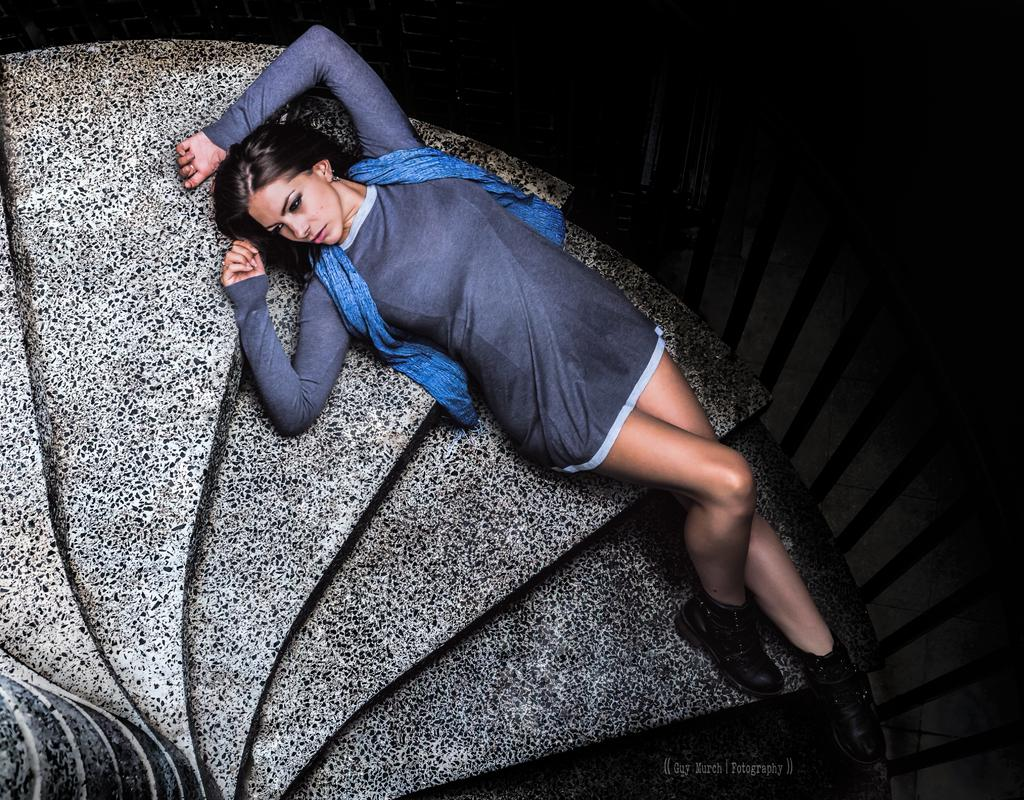What is the woman in the image doing? The woman is lying on the stairs in the image. What can be seen on the right side of the image? There is railing on the right side of the image. How would you describe the lighting in the image? The view is dark in the image. Is there any text or marking visible in the image? Yes, there is a watermark at the bottom of the image. Can you see a lake in the image? No, there is no lake present in the image. What color is the sky in the image? The provided facts do not mention the sky, so we cannot determine its color from the image. 